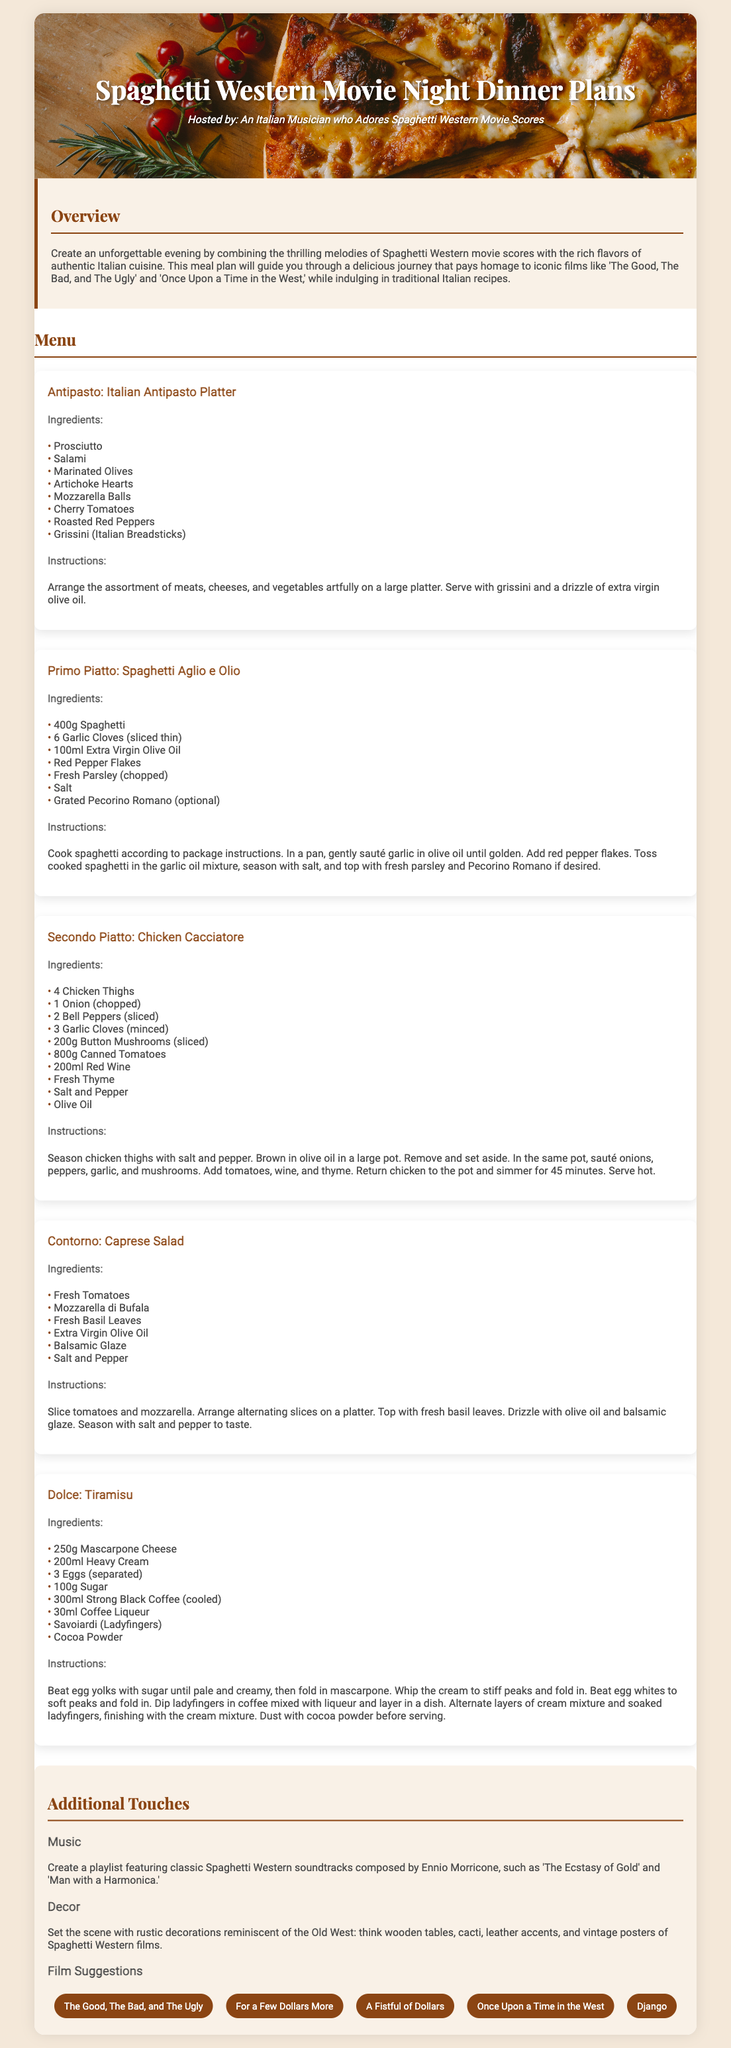What is the host's persona? The host is described as an "Italian Musician who Adores Spaghetti Western Movie Scores."
Answer: Italian Musician who Adores Spaghetti Western Movie Scores What is the first course listed in the menu? The first course listed in the menu is the Antipasto.
Answer: Antipasto How many cloves of garlic are in the Spaghetti Aglio e Olio? The recipe for Spaghetti Aglio e Olio calls for 6 garlic cloves.
Answer: 6 garlic cloves What ingredient is optional in the Spaghetti Aglio e Olio? The optional ingredient in the Spaghetti Aglio e Olio is Grated Pecorino Romano.
Answer: Grated Pecorino Romano How long should the Chicken Cacciatore be simmered? The Chicken Cacciatore should be simmered for 45 minutes.
Answer: 45 minutes What are the main ingredients in the Caprese Salad? The main ingredients in the Caprese Salad are Fresh Tomatoes, Mozzarella di Bufala, and Fresh Basil Leaves.
Answer: Fresh Tomatoes, Mozzarella di Bufala, Fresh Basil Leaves Which film is suggested for the movie night? One of the film suggestions is "The Good, The Bad, and The Ugly."
Answer: The Good, The Bad, and The Ugly What dessert is featured in the menu? The dessert featured in the menu is Tiramisu.
Answer: Tiramisu What should the decor theme resemble? The decor theme should resemble the Old West.
Answer: Old West 